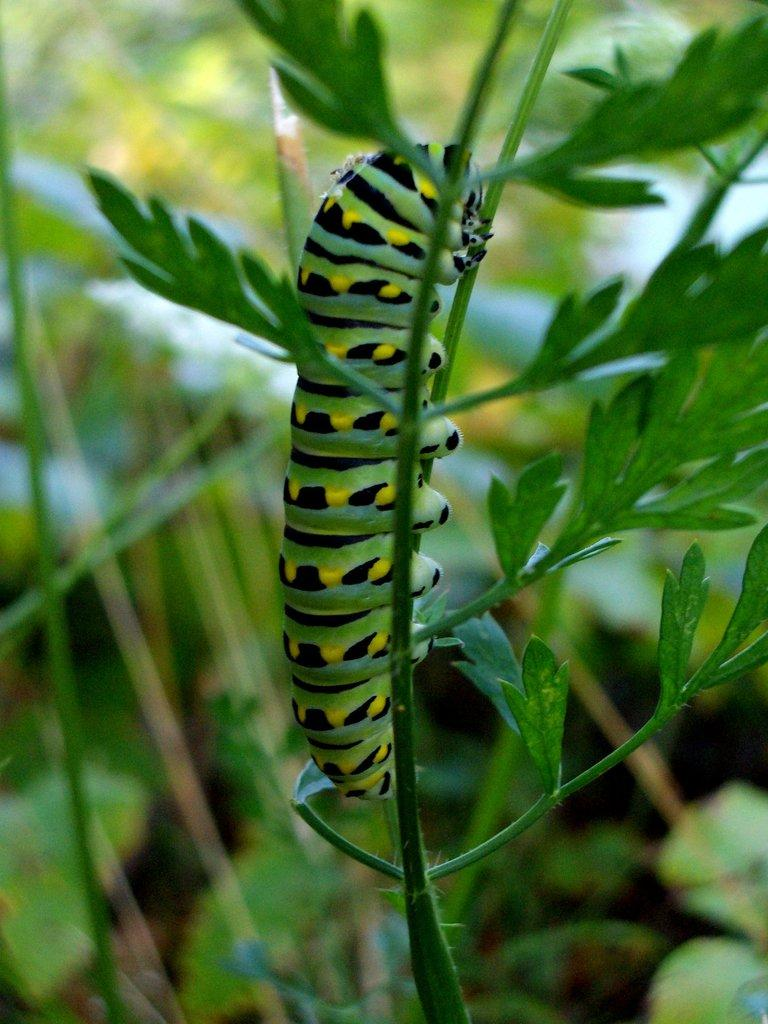What is located in the foreground of the image? There is a plant and an insect in the foreground of the image. Can you describe the background of the image? The background of the image is blurry. What type of carpenter is visible in the image? There is no carpenter present in the image. What is the chin of the kitten doing in the image? There is no kitten present in the image, so its chin cannot be observed. 